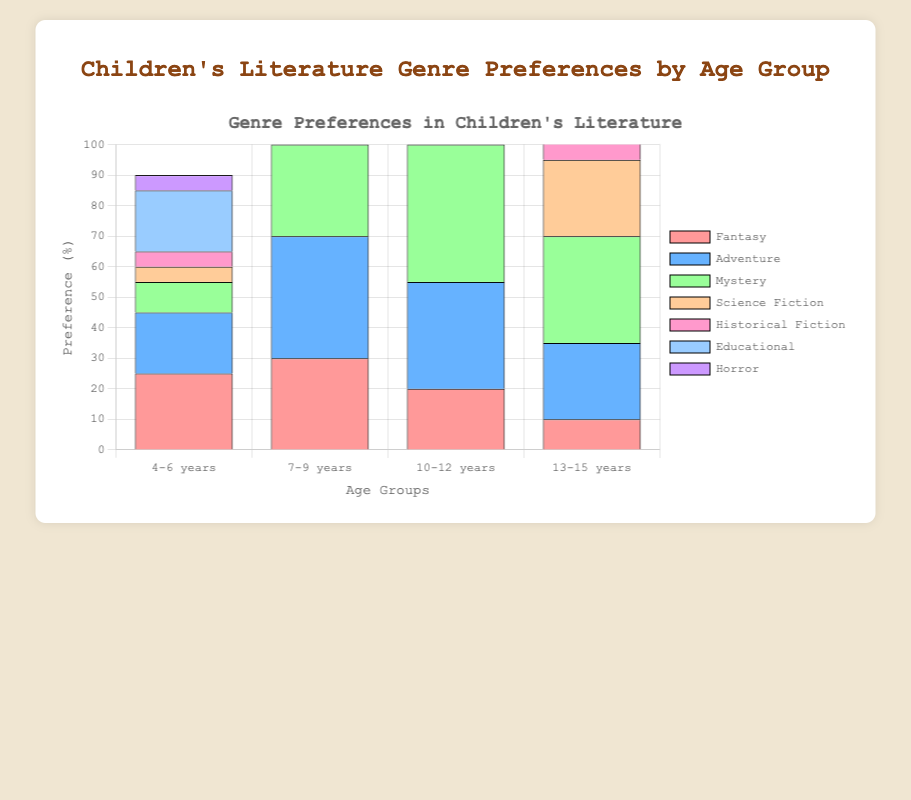Which age group prefers Mystery the most? To determine which age group prefers Mystery the most, look for the tallest bar segment labeled 'Mystery'. The '10-12 years' group has the highest bar for Mystery.
Answer: 10-12 years Among '7-9 years' and '10-12 years', which age group has a higher preference for Horror? To compare the preference for Horror between '7-9 years' and '10-12 years', observe the height of the 'Horror' bar segments for these groups. The '10-12 years' group has a taller bar segment for Horror.
Answer: 10-12 years What is the total preference percentage for genres other than Adventure in the '13-15 years' group? First, note the percentage for Adventure in the '13-15 years' group (25%). Then, sum the percentages of all genres in this group (10+25+35+25+20+5+40 = 160). The total preference for all genres other than Adventure is 160 - 25 = 135. So, (135/160)*100 = 84.375%.
Answer: 84.375% Which genre is preferred the least by the '4-6 years' age group? To find the least preferred genre for the '4-6 years' age group, identify the smallest bar segment. The smallest segment is 'Science Fiction' at 5%.
Answer: Science Fiction Compare the preference percentages for Fantasy between '4-6 years' and '13-15 years'. What is the difference? The preference percentage for Fantasy among '4-6 years' is 25%. For '13-15 years', it is 10%. The difference is 25% - 10% = 15%.
Answer: 15% What is the combined preference percentage for Educational and Historical Fiction in '7-9 years'? The preference percentage for Educational in '7-9 years' is 25%. For Historical Fiction, it is 10%. The combined preference is 25% + 10% = 35%.
Answer: 35% How does the preference for Adventure change from '4-6 years' to '13-15 years'? The preference percentages for Adventure across age groups are: '4-6 years' (20%), '13-15 years' (25%). The change is 25% - 20% = 5% increase.
Answer: 5% increase 